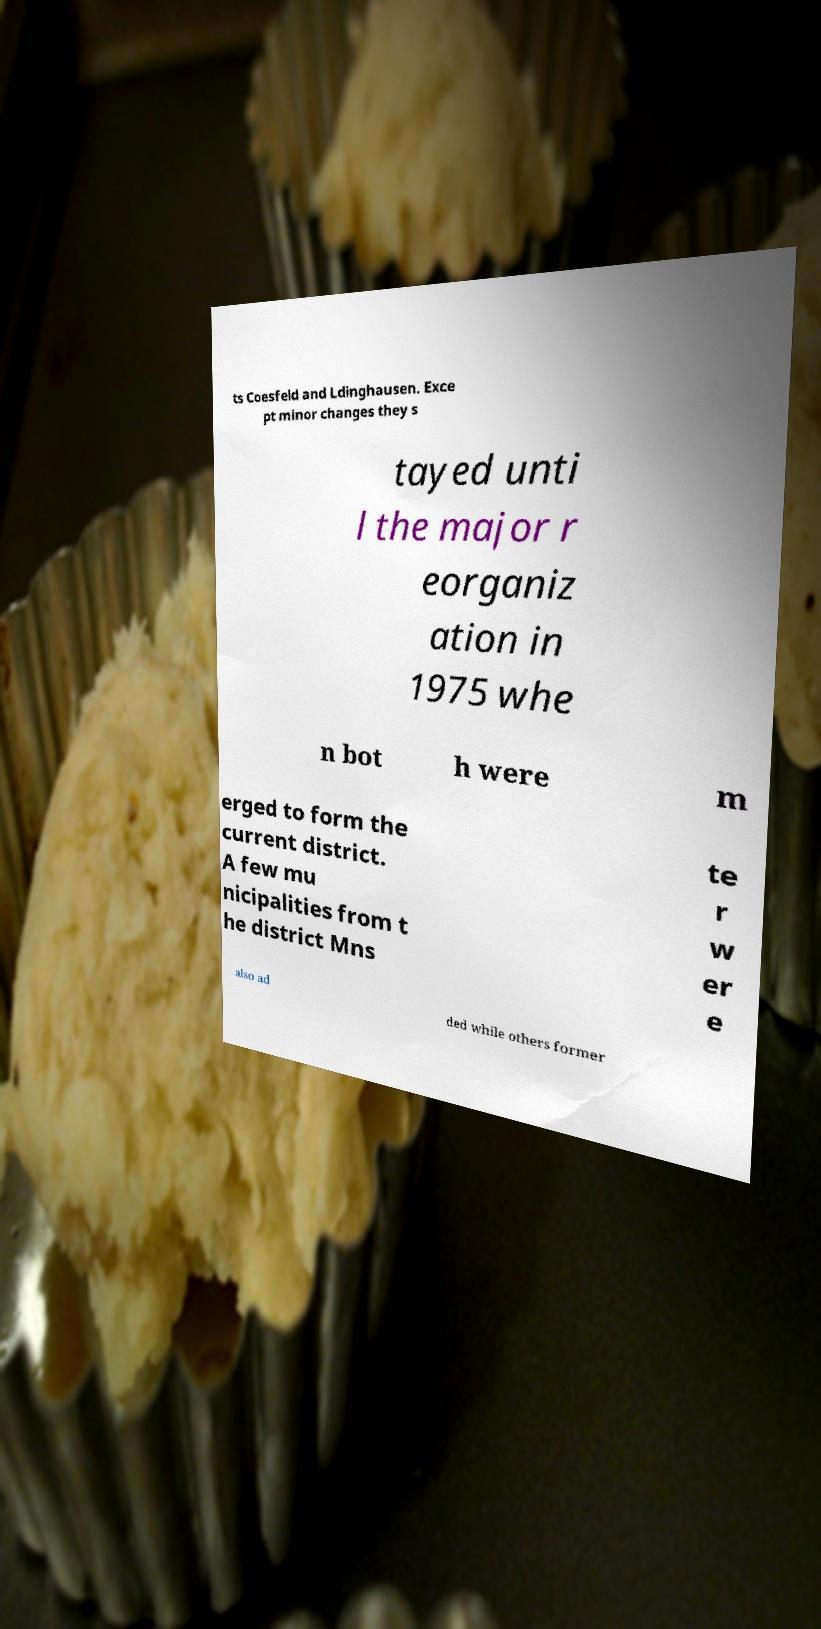I need the written content from this picture converted into text. Can you do that? ts Coesfeld and Ldinghausen. Exce pt minor changes they s tayed unti l the major r eorganiz ation in 1975 whe n bot h were m erged to form the current district. A few mu nicipalities from t he district Mns te r w er e also ad ded while others former 